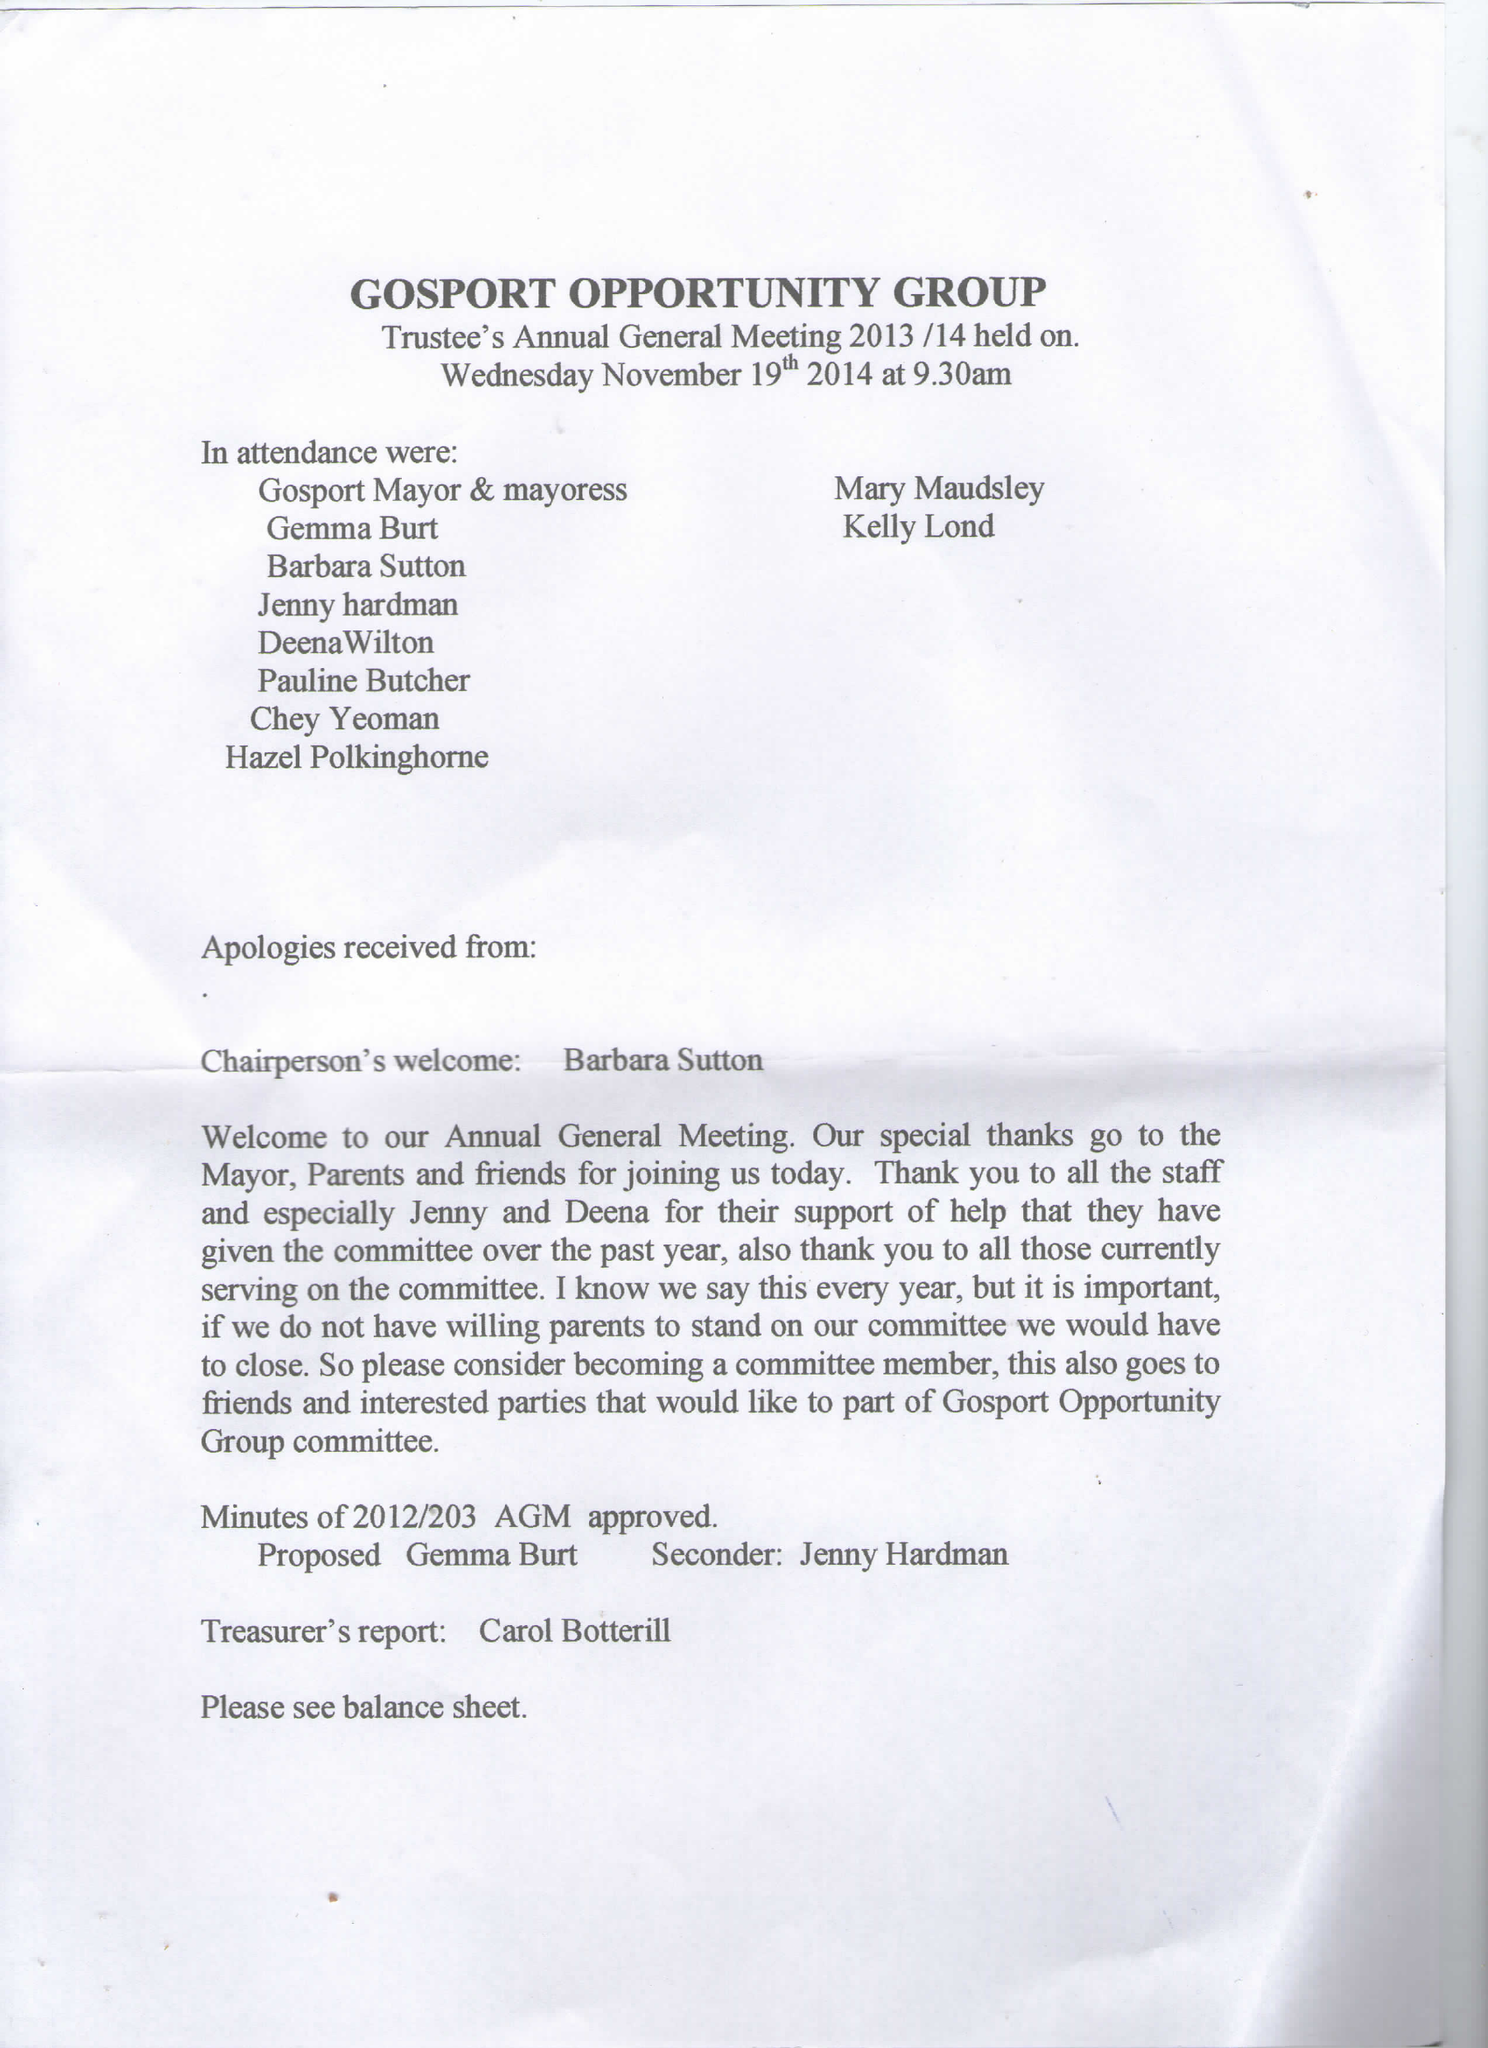What is the value for the address__post_town?
Answer the question using a single word or phrase. GOSPORT 